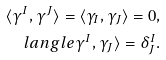<formula> <loc_0><loc_0><loc_500><loc_500>\langle \gamma ^ { I } , \gamma ^ { J } \rangle = \langle \gamma _ { I } , \gamma _ { J } \rangle = 0 , \\ l a n g l e \gamma ^ { I } , \gamma _ { J } \rangle = \delta ^ { I } _ { J } .</formula> 